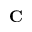Convert formula to latex. <formula><loc_0><loc_0><loc_500><loc_500>C</formula> 